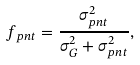<formula> <loc_0><loc_0><loc_500><loc_500>f _ { p n t } = \frac { \sigma ^ { 2 } _ { p n t } } { \sigma ^ { 2 } _ { G } + \sigma ^ { 2 } _ { p n t } } ,</formula> 